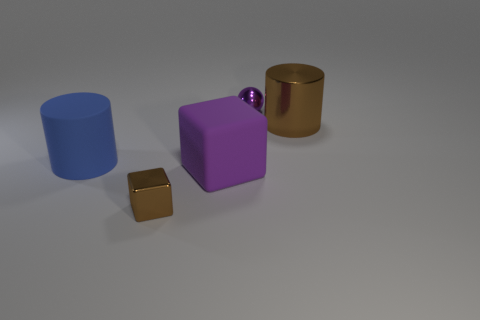Add 5 large red cylinders. How many objects exist? 10 Subtract 1 cylinders. How many cylinders are left? 1 Subtract all cubes. How many objects are left? 3 Subtract 1 purple balls. How many objects are left? 4 Subtract all tiny purple metallic things. Subtract all large blocks. How many objects are left? 3 Add 2 purple balls. How many purple balls are left? 3 Add 5 purple spheres. How many purple spheres exist? 6 